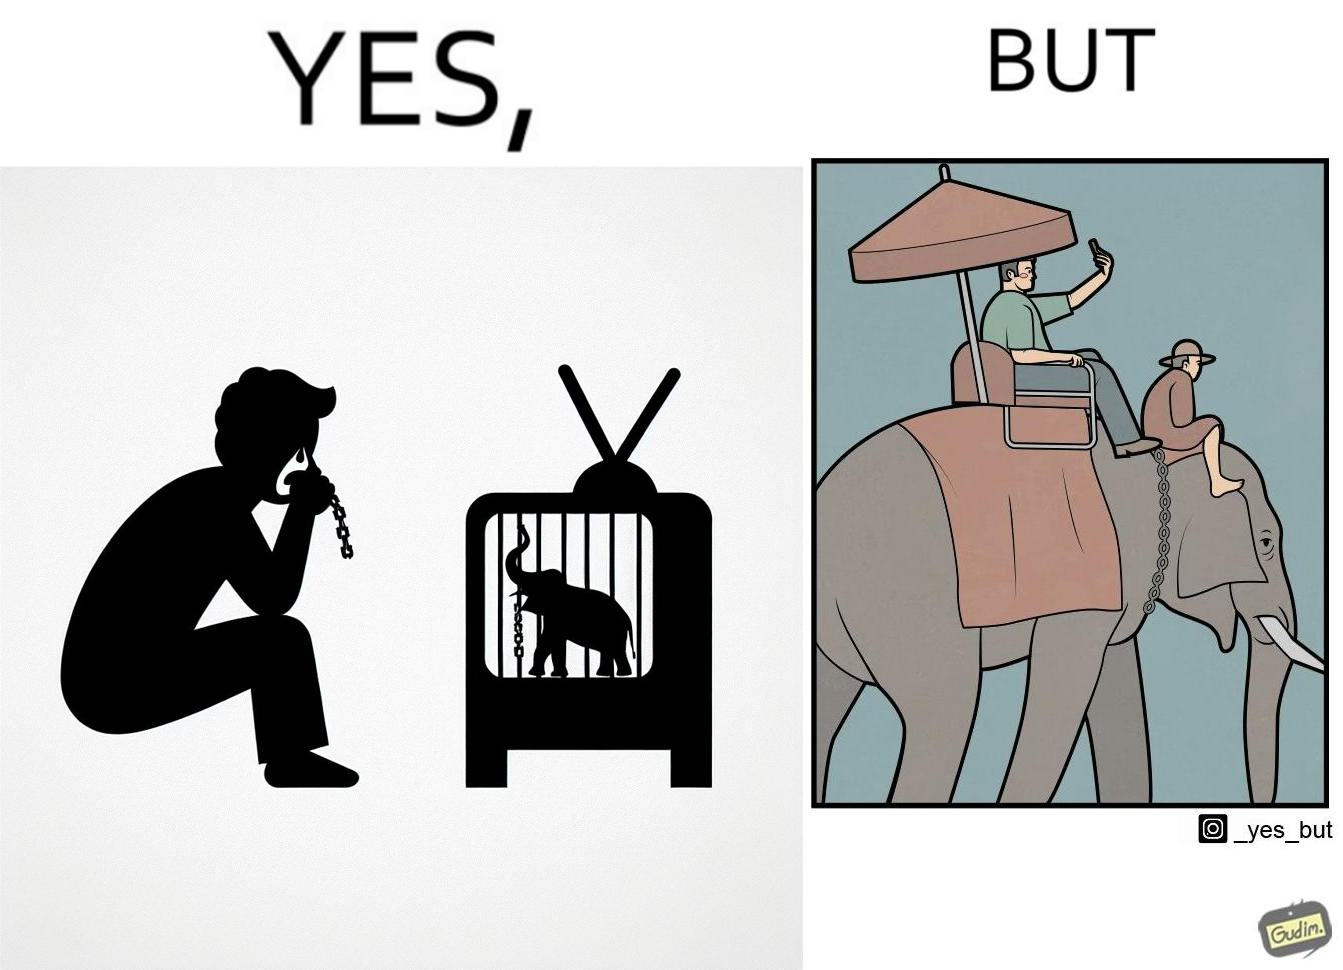Does this image contain satire or humor? Yes, this image is satirical. 